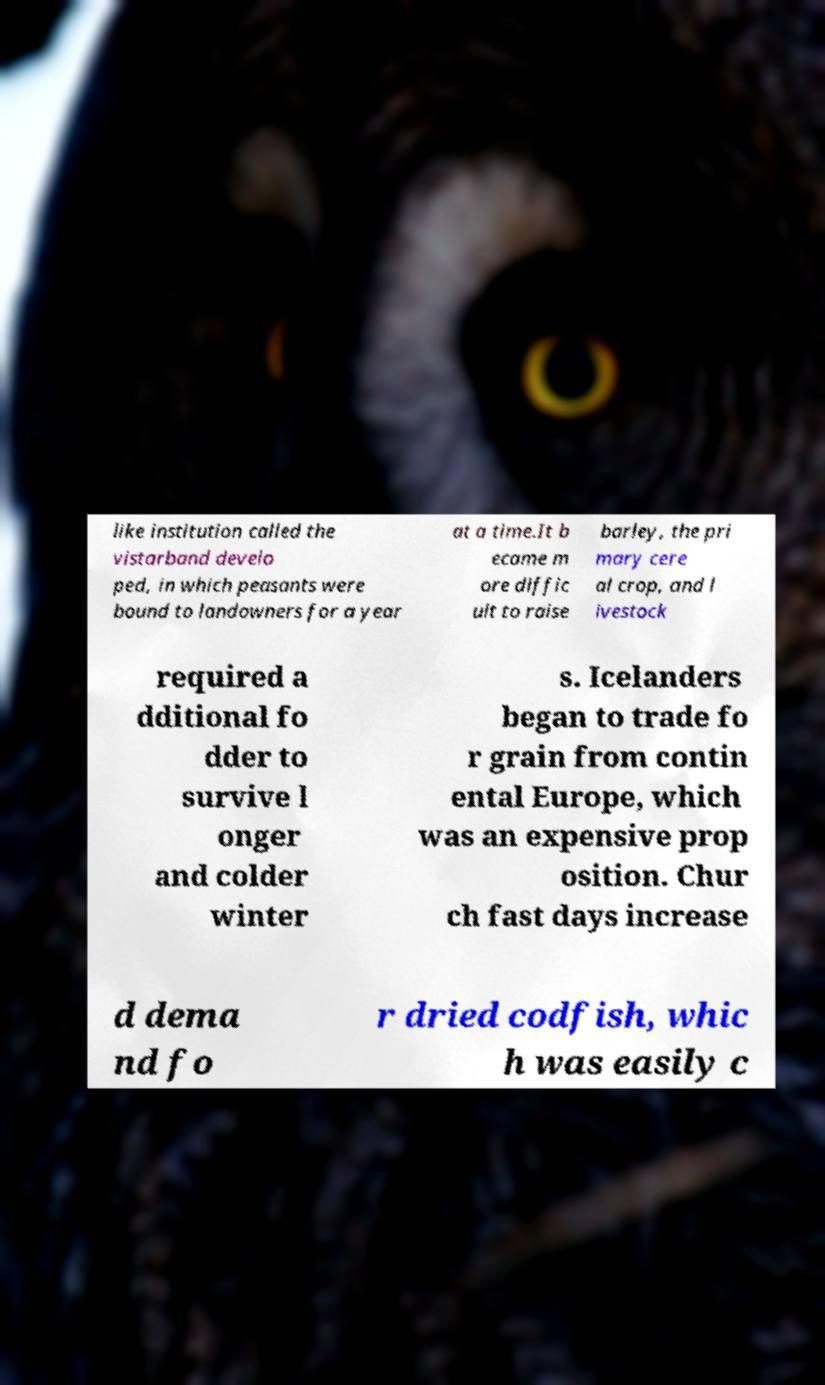Can you accurately transcribe the text from the provided image for me? like institution called the vistarband develo ped, in which peasants were bound to landowners for a year at a time.It b ecame m ore diffic ult to raise barley, the pri mary cere al crop, and l ivestock required a dditional fo dder to survive l onger and colder winter s. Icelanders began to trade fo r grain from contin ental Europe, which was an expensive prop osition. Chur ch fast days increase d dema nd fo r dried codfish, whic h was easily c 